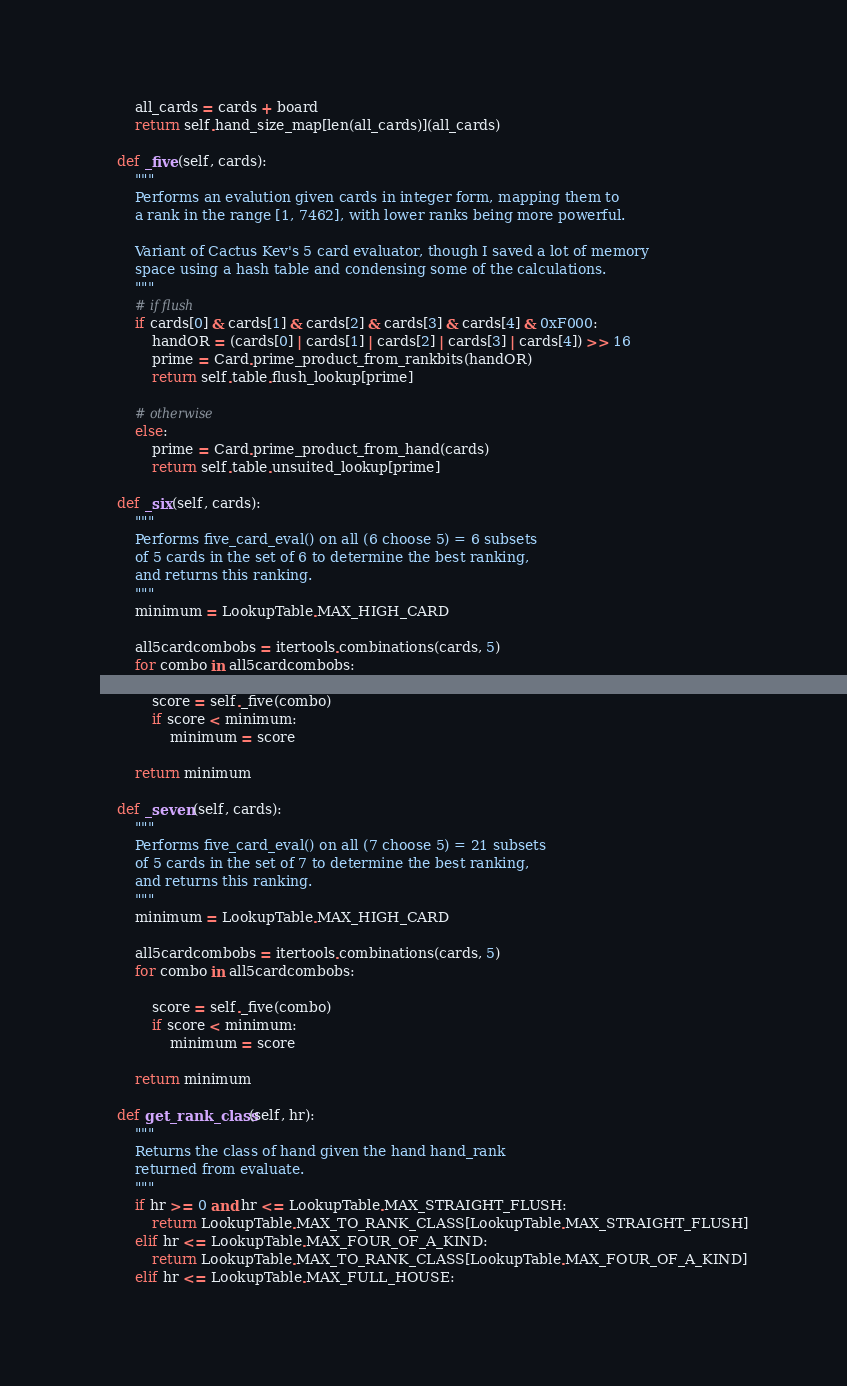<code> <loc_0><loc_0><loc_500><loc_500><_Python_>        all_cards = cards + board
        return self.hand_size_map[len(all_cards)](all_cards)

    def _five(self, cards):
        """
        Performs an evalution given cards in integer form, mapping them to
        a rank in the range [1, 7462], with lower ranks being more powerful.

        Variant of Cactus Kev's 5 card evaluator, though I saved a lot of memory
        space using a hash table and condensing some of the calculations. 
        """
        # if flush
        if cards[0] & cards[1] & cards[2] & cards[3] & cards[4] & 0xF000:
            handOR = (cards[0] | cards[1] | cards[2] | cards[3] | cards[4]) >> 16
            prime = Card.prime_product_from_rankbits(handOR)
            return self.table.flush_lookup[prime]

        # otherwise
        else:
            prime = Card.prime_product_from_hand(cards)
            return self.table.unsuited_lookup[prime]

    def _six(self, cards):
        """
        Performs five_card_eval() on all (6 choose 5) = 6 subsets
        of 5 cards in the set of 6 to determine the best ranking, 
        and returns this ranking.
        """
        minimum = LookupTable.MAX_HIGH_CARD

        all5cardcombobs = itertools.combinations(cards, 5)
        for combo in all5cardcombobs:

            score = self._five(combo)
            if score < minimum:
                minimum = score

        return minimum

    def _seven(self, cards):
        """
        Performs five_card_eval() on all (7 choose 5) = 21 subsets
        of 5 cards in the set of 7 to determine the best ranking, 
        and returns this ranking.
        """
        minimum = LookupTable.MAX_HIGH_CARD

        all5cardcombobs = itertools.combinations(cards, 5)
        for combo in all5cardcombobs:
            
            score = self._five(combo)
            if score < minimum:
                minimum = score

        return minimum

    def get_rank_class(self, hr):
        """
        Returns the class of hand given the hand hand_rank
        returned from evaluate. 
        """
        if hr >= 0 and hr <= LookupTable.MAX_STRAIGHT_FLUSH:
            return LookupTable.MAX_TO_RANK_CLASS[LookupTable.MAX_STRAIGHT_FLUSH]
        elif hr <= LookupTable.MAX_FOUR_OF_A_KIND:
            return LookupTable.MAX_TO_RANK_CLASS[LookupTable.MAX_FOUR_OF_A_KIND]
        elif hr <= LookupTable.MAX_FULL_HOUSE:</code> 